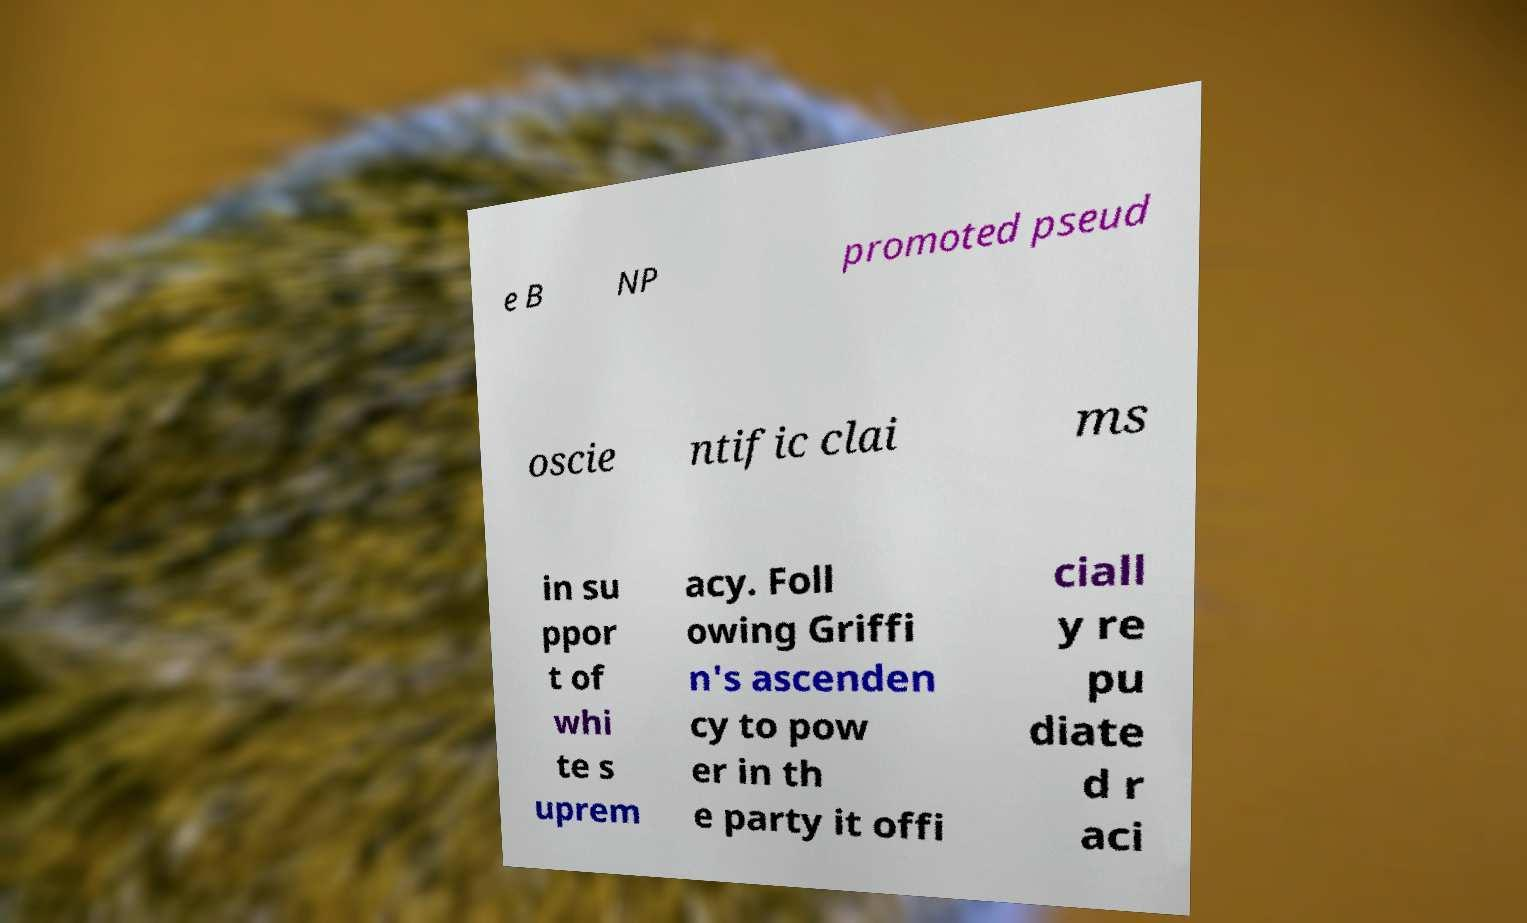Can you read and provide the text displayed in the image?This photo seems to have some interesting text. Can you extract and type it out for me? e B NP promoted pseud oscie ntific clai ms in su ppor t of whi te s uprem acy. Foll owing Griffi n's ascenden cy to pow er in th e party it offi ciall y re pu diate d r aci 